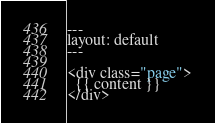Convert code to text. <code><loc_0><loc_0><loc_500><loc_500><_HTML_>---
layout: default
---

<div class="page">
  {{ content }}
</div>
</code> 